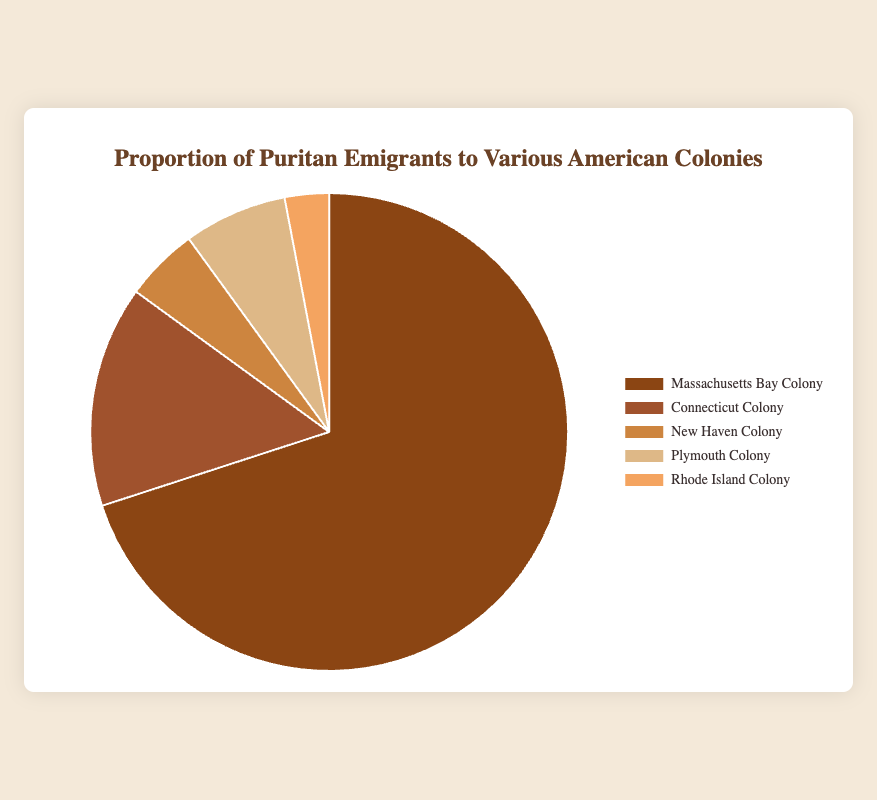What's the proportion of Puritan emigrants to the Plymouth Colony? From the chart, look for the segment labeled "Plymouth Colony" and read its proportion value.
Answer: 7% Which colony received the largest proportion of Puritan emigrants? Identify the segment with the largest size in the pie chart and read its label.
Answer: Massachusetts Bay Colony How does the proportion of emigrants to Connecticut Colony compare with those to New Haven Colony? From the chart, note the proportions of Connecticut Colony and New Haven Colony. Connecticut Colony received 15%, while New Haven Colony received 5%.
Answer: Connecticut Colony received 10% more Which colony has the smallest proportion of emigrants, and what is that proportion? Find the smallest segment in the pie chart and read its proportion.
Answer: Rhode Island Colony, 3% What's the combined proportion of emigrants to Connecticut and Plymouth Colonies? Add the proportions of Connecticut Colony (15%) and Plymouth Colony (7%). 15 + 7 = 22%
Answer: 22% How does the proportion of emigrants to the New Haven Colony and Rhode Island Colony combined compare to those to Connecticut Colony? Add the proportions of New Haven Colony (5%) and Rhode Island Colony (3%), then compare to Connecticut Colony (15%). 5 + 3 = 8%, which is less than 15%.
Answer: Less than Connecticut What proportion of emigrants went to colonies other than Massachusetts Bay Colony? Subtract the proportion of Massachusetts Bay Colony (70%) from 100%. 100 - 70 = 30%
Answer: 30% Which colony's segment is the second-largest in the pie chart? Identify the second-largest segment in the pie chart next to Massachusetts Bay Colony.
Answer: Connecticut Colony What’s the difference in the proportion of emigrants between the Plymouth Colony and New Haven Colony? Subtract the proportion of New Haven Colony (5%) from Plymouth Colony (7%). 7 - 5 = 2%
Answer: 2% What color is associated with the Plymouth Colony segment in the pie chart? Observe the color fill of the segment labeled "Plymouth Colony".
Answer: Light brown 